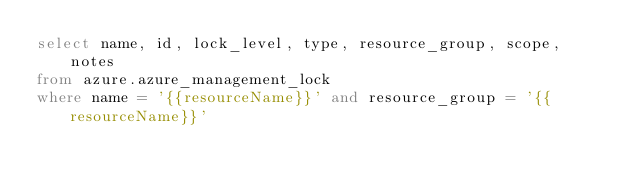<code> <loc_0><loc_0><loc_500><loc_500><_SQL_>select name, id, lock_level, type, resource_group, scope, notes
from azure.azure_management_lock
where name = '{{resourceName}}' and resource_group = '{{resourceName}}'
</code> 